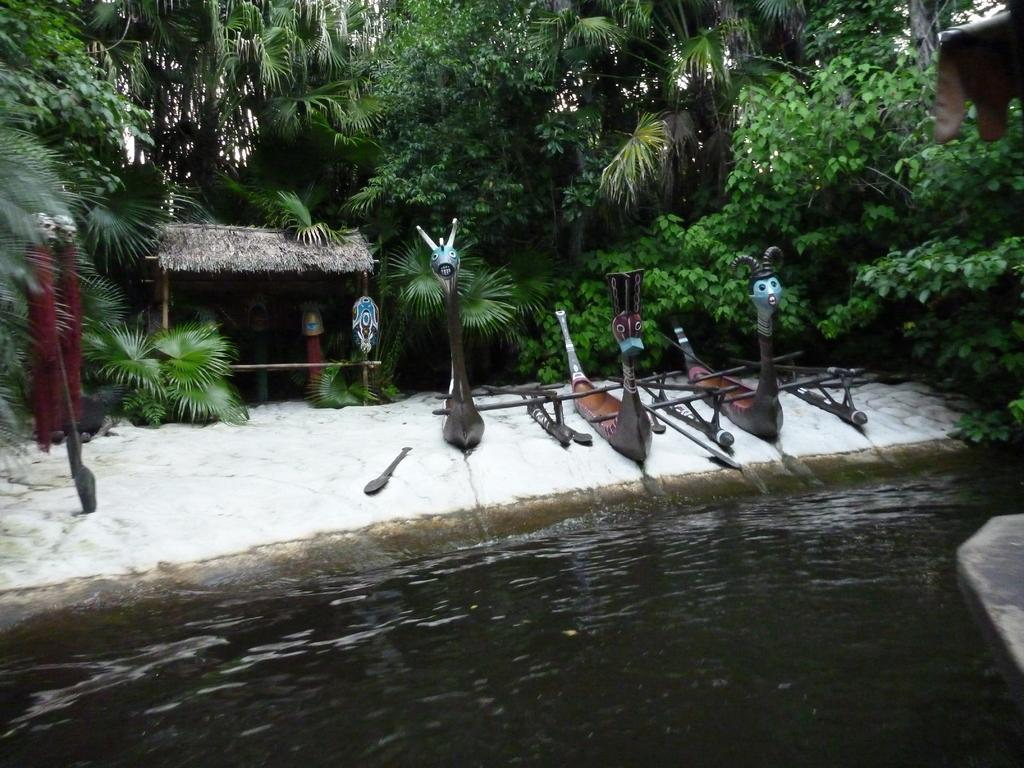What type of natural feature is present in the image? There is a lake in the image. What objects can be seen near the lake? There are boards and a small hut visible in the image. What type of vegetation is in the background of the image? There are trees in the background of the image. What type of furniture is present in the image? There is no furniture present in the image. What is the opinion of the trees in the background of the image? The trees in the background of the image do not have an opinion, as they are inanimate objects and cannot express opinions. 